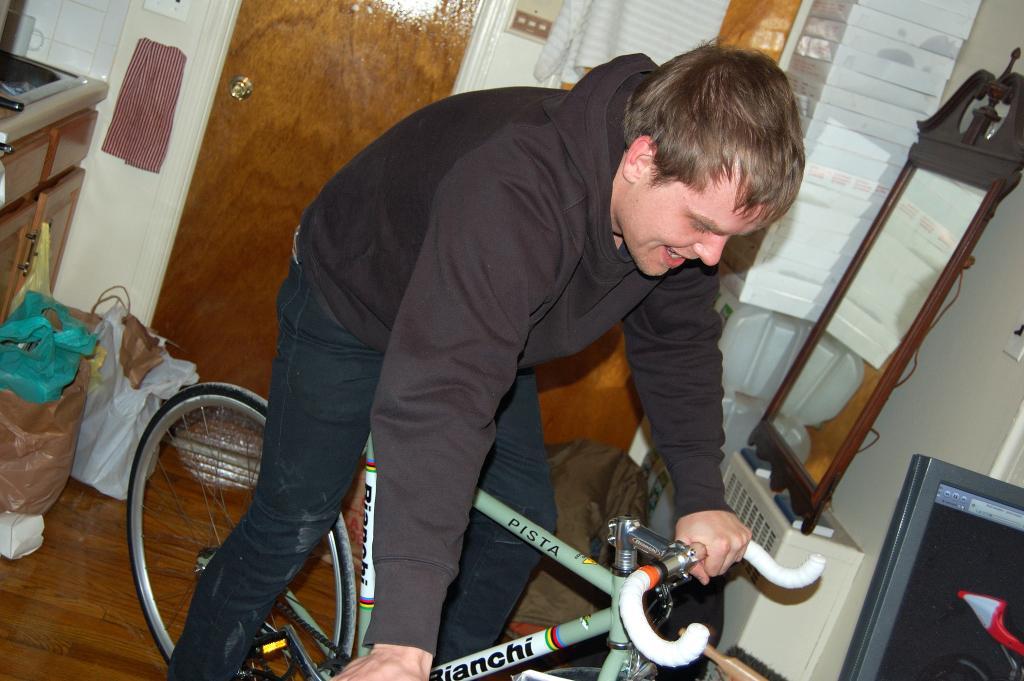How would you summarize this image in a sentence or two? In this image there is a person sitting on the cycle. At the bottom of the image there is a floor. Behind him there is a door. On the left side of the image there are covers. There is a table. On the right side of the image there is a dressing table. There is a computer. There is a wall and there are a few other objects. 